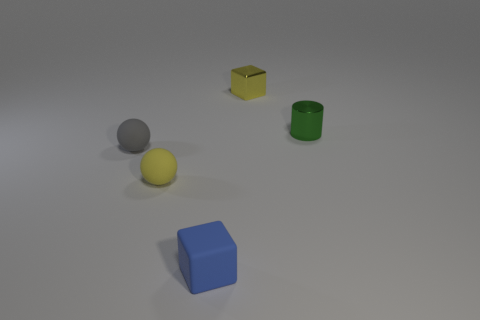Are there fewer small blue cylinders than small green cylinders? yes 